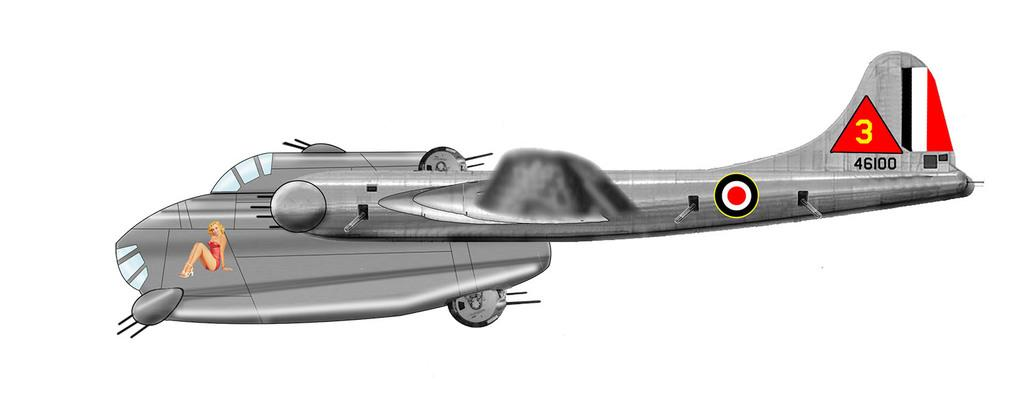What is the main subject of the picture? The main subject of the picture is an animated image of a plane. What is depicted on the plane in the image? The plane has a picture of a woman in a sitting position. What type of treatment is the woman receiving in the image? There is no indication in the image that the woman is receiving any treatment, as it is an animated image of a plane with a picture of a woman in a sitting position. 